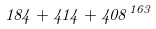<formula> <loc_0><loc_0><loc_500><loc_500>1 8 4 + 4 1 4 + 4 0 8 ^ { 1 6 3 }</formula> 